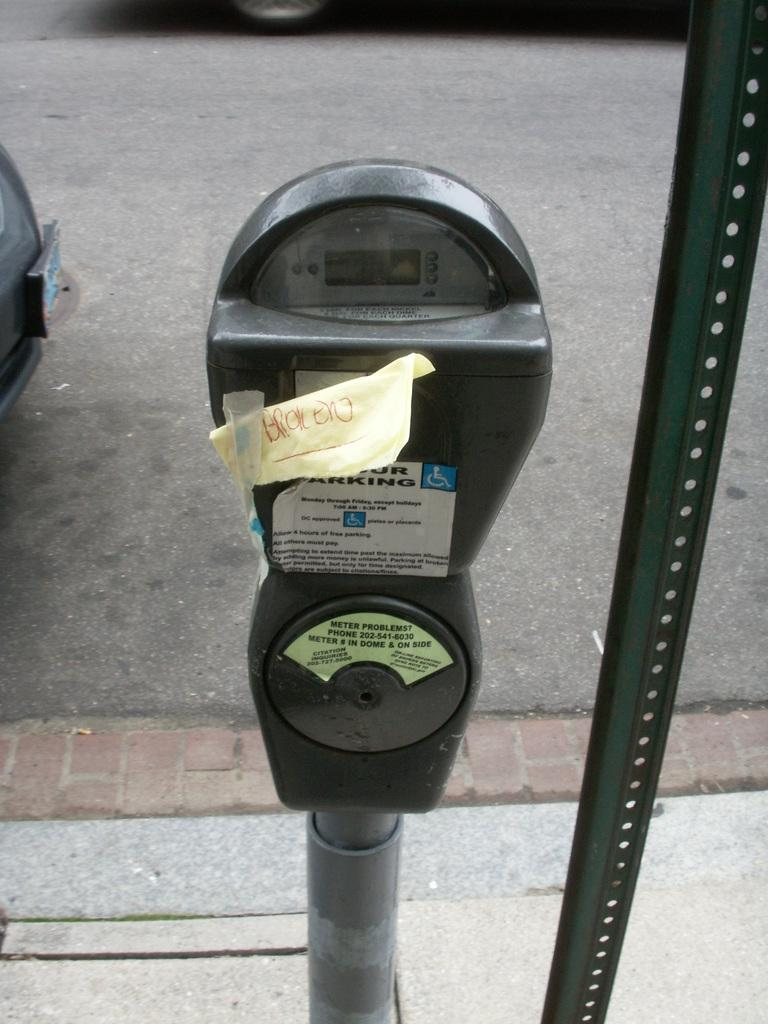Provide a one-sentence caption for the provided image. A parking meter with a note taped on the coin slot that says broken. 